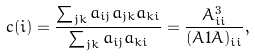<formula> <loc_0><loc_0><loc_500><loc_500>c ( i ) = \frac { \sum _ { j k } a _ { i j } a _ { j k } a _ { k i } } { \sum _ { j k } a _ { i j } a _ { k i } } = \frac { A ^ { 3 } _ { i i } } { ( A 1 A ) _ { i i } } ,</formula> 